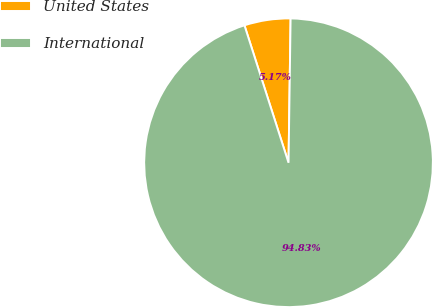<chart> <loc_0><loc_0><loc_500><loc_500><pie_chart><fcel>United States<fcel>International<nl><fcel>5.17%<fcel>94.83%<nl></chart> 